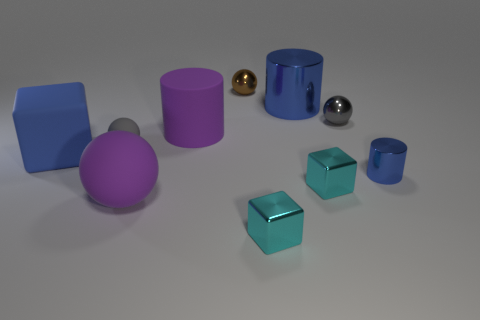Subtract all large balls. How many balls are left? 3 Subtract 0 red spheres. How many objects are left? 10 Subtract all cylinders. How many objects are left? 7 Subtract 3 cylinders. How many cylinders are left? 0 Subtract all gray spheres. Subtract all gray cylinders. How many spheres are left? 2 Subtract all green spheres. How many purple blocks are left? 0 Subtract all small brown spheres. Subtract all rubber spheres. How many objects are left? 7 Add 8 small cylinders. How many small cylinders are left? 9 Add 5 big cyan matte blocks. How many big cyan matte blocks exist? 5 Subtract all cyan cubes. How many cubes are left? 1 